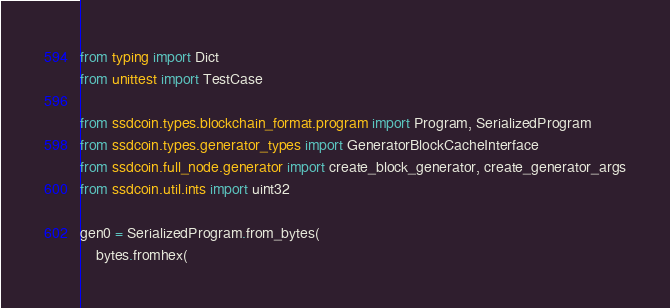<code> <loc_0><loc_0><loc_500><loc_500><_Python_>from typing import Dict
from unittest import TestCase

from ssdcoin.types.blockchain_format.program import Program, SerializedProgram
from ssdcoin.types.generator_types import GeneratorBlockCacheInterface
from ssdcoin.full_node.generator import create_block_generator, create_generator_args
from ssdcoin.util.ints import uint32

gen0 = SerializedProgram.from_bytes(
    bytes.fromhex(</code> 